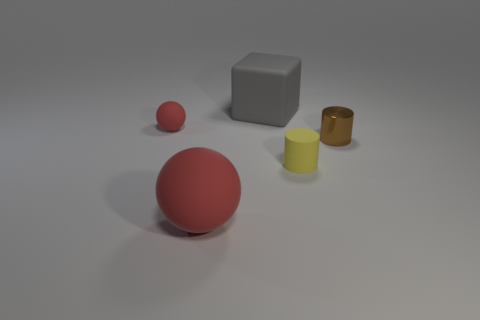Add 3 big purple spheres. How many objects exist? 8 Subtract 0 red cubes. How many objects are left? 5 Subtract all cylinders. How many objects are left? 3 Subtract 1 cubes. How many cubes are left? 0 Subtract all green spheres. Subtract all brown cubes. How many spheres are left? 2 Subtract all cyan blocks. How many yellow balls are left? 0 Subtract all tiny cylinders. Subtract all gray matte objects. How many objects are left? 2 Add 2 tiny brown cylinders. How many tiny brown cylinders are left? 3 Add 1 gray rubber cylinders. How many gray rubber cylinders exist? 1 